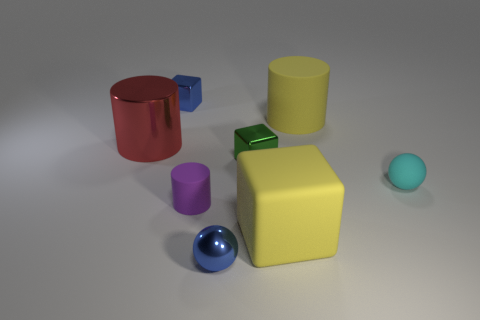What number of tiny yellow balls are there?
Keep it short and to the point. 0. The matte cylinder that is in front of the rubber sphere is what color?
Offer a very short reply. Purple. There is a big rubber cylinder that is behind the ball that is in front of the purple rubber thing; what color is it?
Ensure brevity in your answer.  Yellow. The other ball that is the same size as the shiny ball is what color?
Keep it short and to the point. Cyan. How many small metal objects are behind the yellow cylinder and in front of the tiny cyan sphere?
Offer a very short reply. 0. There is a big object that is the same color as the large rubber block; what shape is it?
Your response must be concise. Cylinder. There is a tiny thing that is both in front of the small cyan object and to the right of the tiny matte cylinder; what material is it?
Ensure brevity in your answer.  Metal. Is the number of shiny objects behind the red cylinder less than the number of shiny objects behind the tiny green metal object?
Your response must be concise. Yes. What is the size of the blue sphere that is made of the same material as the tiny blue cube?
Provide a succinct answer. Small. Is there any other thing that has the same color as the metallic cylinder?
Provide a short and direct response. No. 